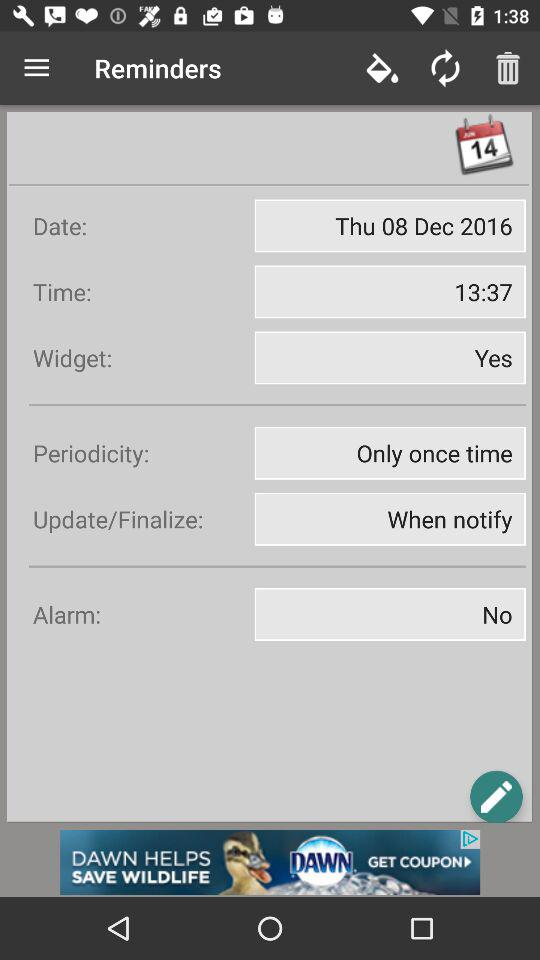How many items have the label 'Alarm'?
Answer the question using a single word or phrase. 1 